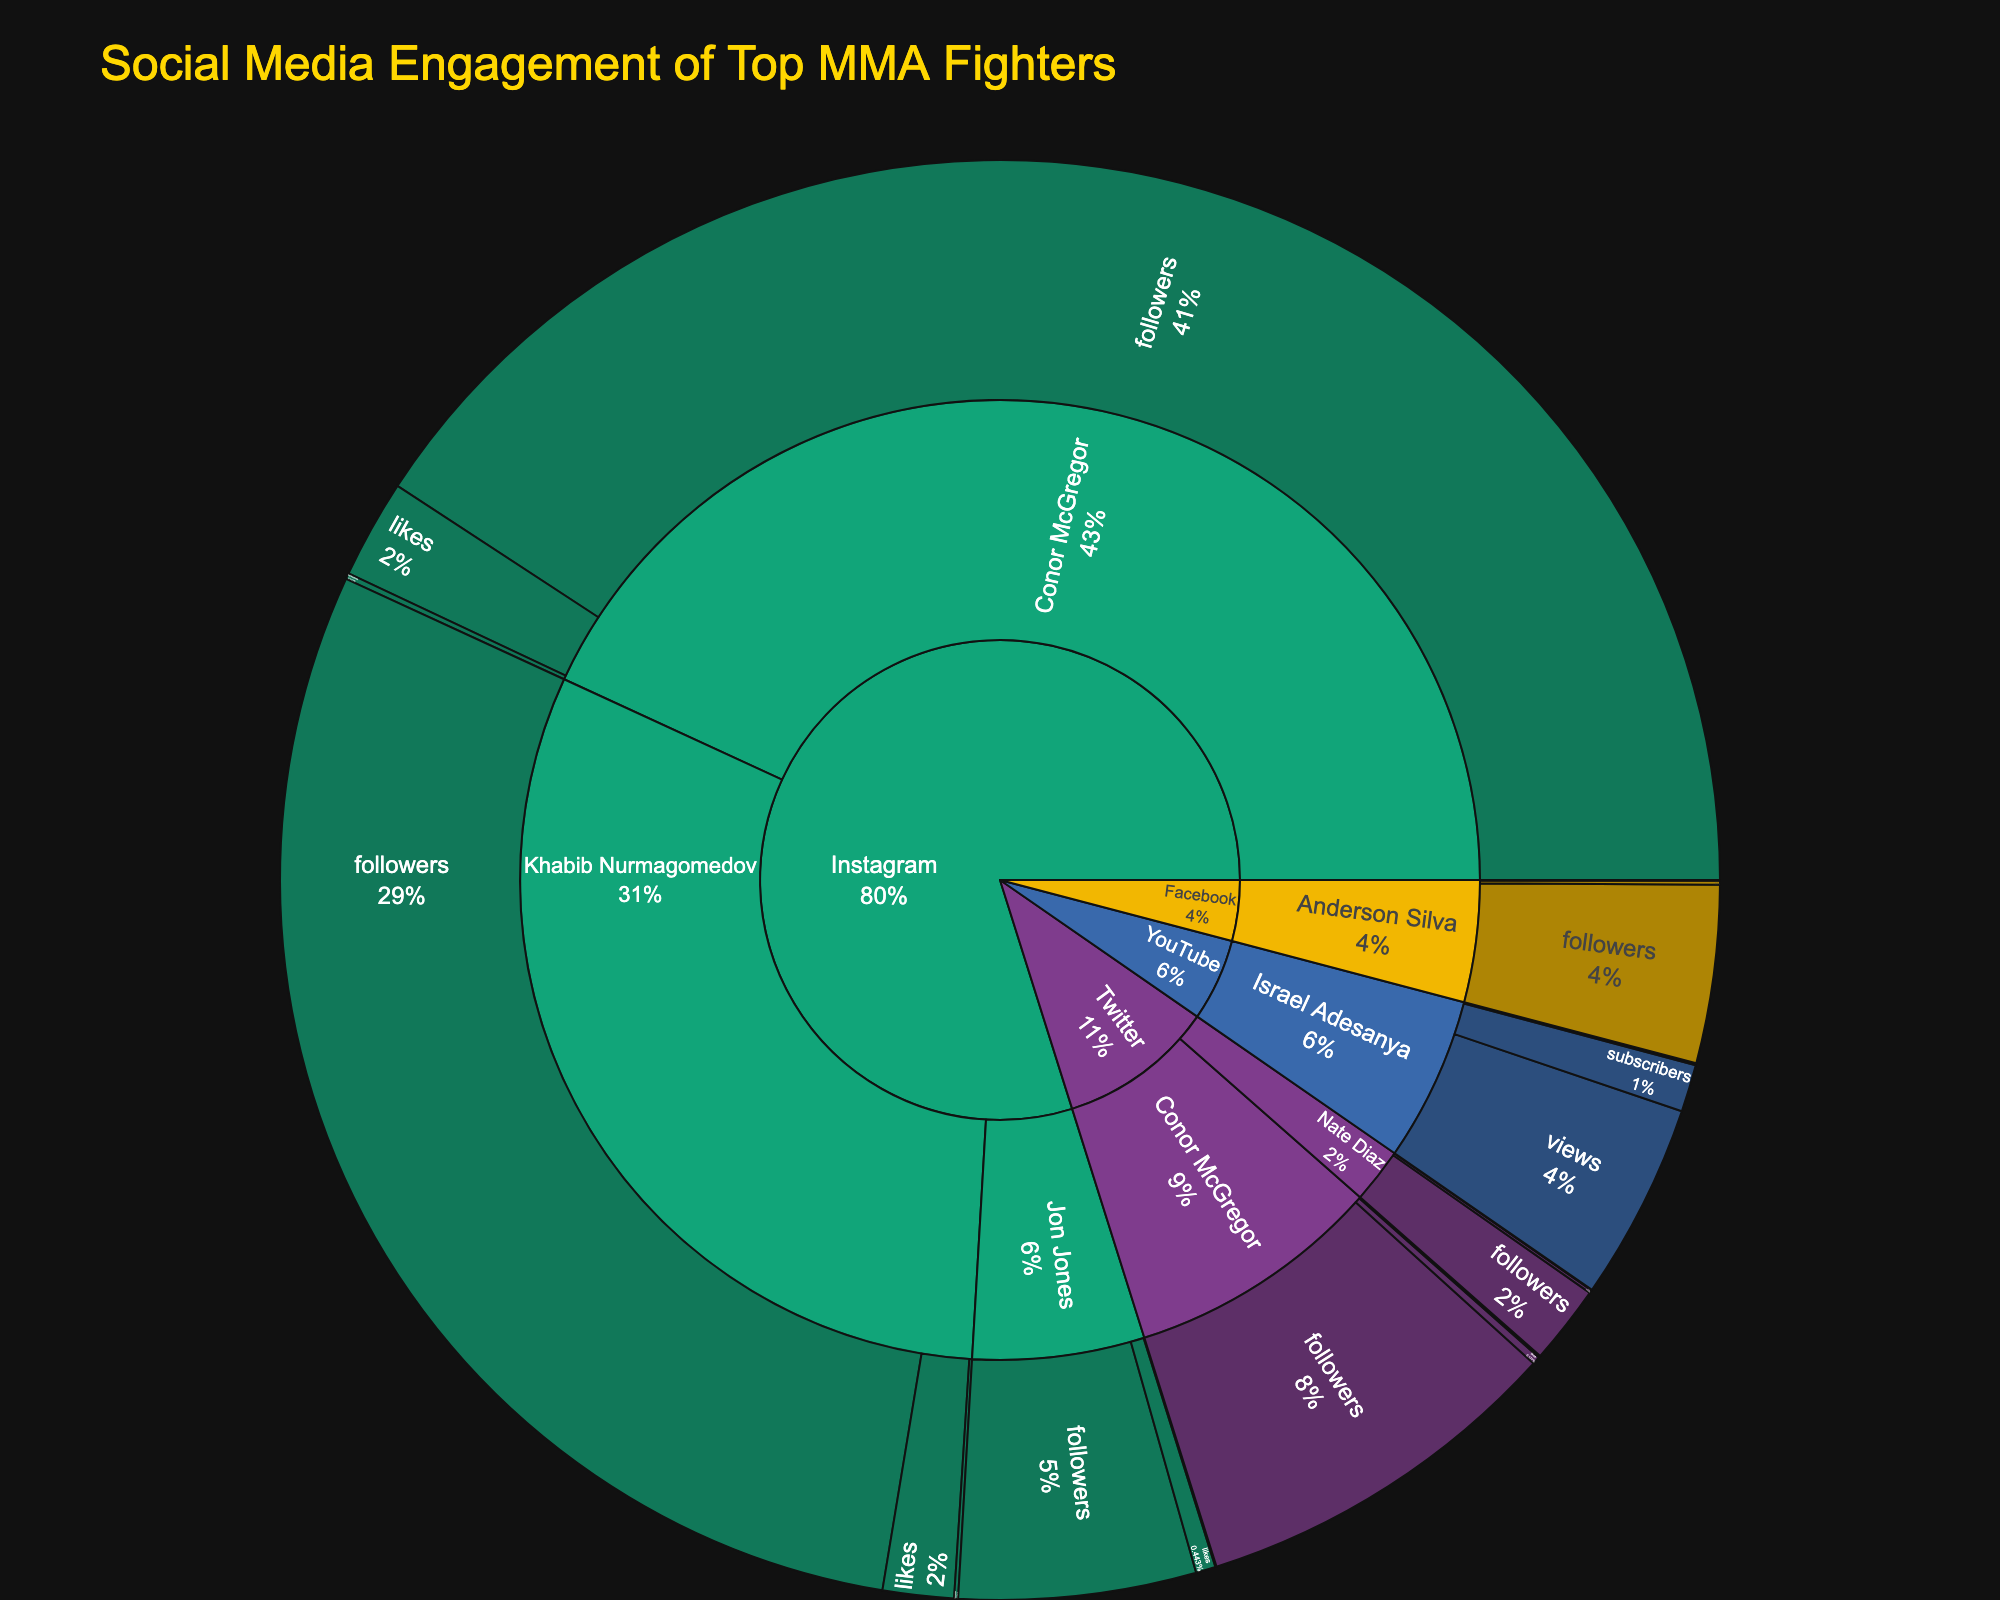How many fighters have Instagram as their primary social media platform? Reviewing the sunburst plot, we identify the fighters under the Instagram section of the hierarchy. There are three fighters listed: Conor McGregor, Khabib Nurmagomedov, and Jon Jones.
Answer: 3 Which fighter has the highest number of followers on Instagram? Within the Instagram section of the sunburst plot, Conor McGregor has the highest value for followers at 46,000,000.
Answer: Conor McGregor What is the total number of likes for Conor McGregor across all platforms? Check the individual values of likes for Conor McGregor on Instagram (2,500,000) and Twitter (200,000). Summing these, the total likes are 2,700,000.
Answer: 2,700,000 Which platform has the least representation in terms of the number of fighters? In the sunburst plot, Facebook and YouTube each have one fighter (Anderson Silva and Israel Adesanya, respectively), while Instagram and Twitter have multiple fighters.
Answer: Facebook and YouTube Who has more followers on their respective primary platform, Nate Diaz on Twitter or Israel Adesanya on YouTube? Evaluate the sunburst plot for Nate Diaz on Twitter (2,000,000 followers) and Israel Adesanya on YouTube (1,200,000 subscribers). Nate Diaz has more followers/subscribers.
Answer: Nate Diaz What's the total value of comments for all fighters on Instagram? Sum the comments for Conor McGregor (150,000), Khabib Nurmagomedov (100,000), and Jon Jones (30,000). The total is 280,000 comments.
Answer: 280,000 Compare the number of followers between Jon Jones on Instagram and Anderson Silva on Facebook. Jon Jones has 6,000,000 followers on Instagram, while Anderson Silva has 4,500,000 on Facebook. Jon Jones has more followers.
Answer: Jon Jones Describe the engagement type with the lowest overall values across all platforms. Review the sunburst plot and find the engagement types with the lowest values. The categories with the smallest numbers are typically "shares" on Facebook (20,000) and "retweets" on Twitter (15,000).
Answer: Shares on Facebook and retweets on Twitter Which two fighters are represented on the most distinct platforms? By checking the sunburst plot, Conor McGregor is represented on Instagram and Twitter, while the other fighters are on a single platform. Therefore, Conor McGregor features on the most distinct platforms.
Answer: Conor McGregor 